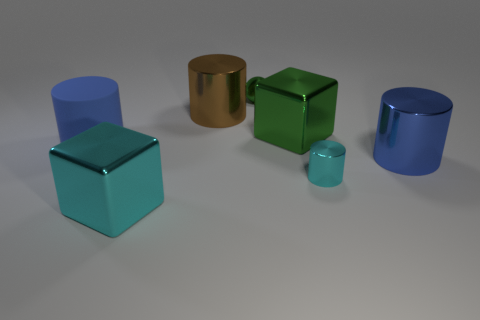Add 2 big metallic blocks. How many objects exist? 9 Subtract all balls. How many objects are left? 6 Subtract 0 gray cylinders. How many objects are left? 7 Subtract all large metallic cylinders. Subtract all large blue matte cylinders. How many objects are left? 4 Add 3 big green metal blocks. How many big green metal blocks are left? 4 Add 2 cyan shiny blocks. How many cyan shiny blocks exist? 3 